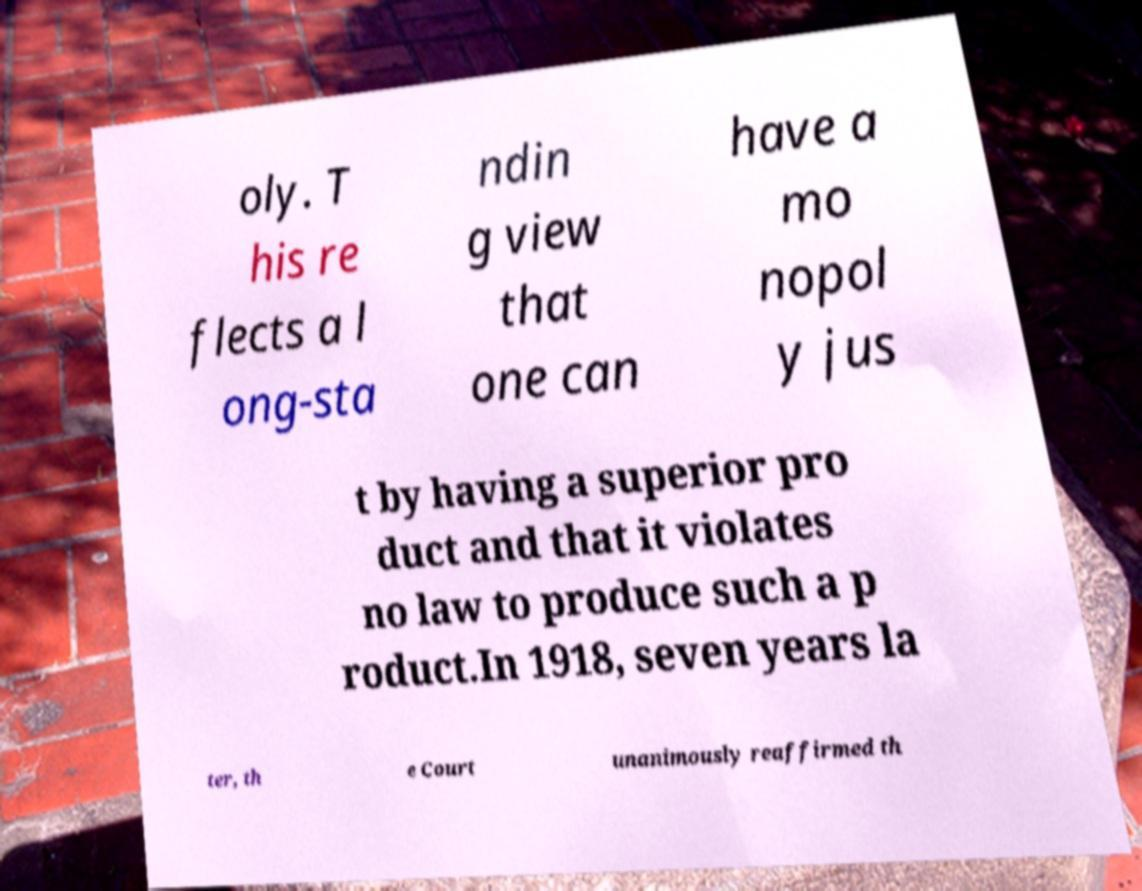Can you accurately transcribe the text from the provided image for me? oly. T his re flects a l ong-sta ndin g view that one can have a mo nopol y jus t by having a superior pro duct and that it violates no law to produce such a p roduct.In 1918, seven years la ter, th e Court unanimously reaffirmed th 